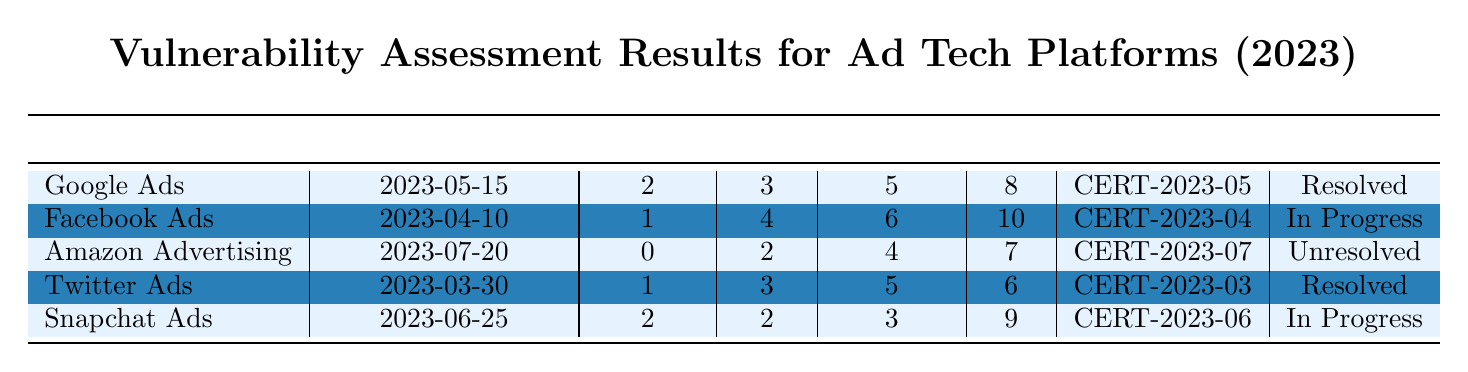What is the status of the vulnerabilities in Facebook Ads? The table shows that Facebook Ads has a status of "In Progress" listed under the Status column.
Answer: In Progress How many critical vulnerabilities were found in Google Ads? Referring to the Google Ads row, the Critical column shows 2 vulnerabilities.
Answer: 2 Which platform has the highest number of high vulnerabilities? By examining the High column, Facebook Ads has 4 high vulnerabilities, which is the maximum compared to other platforms.
Answer: Facebook Ads What is the total number of low vulnerabilities across all platforms? The Low column contains 8 (Google Ads) + 10 (Facebook Ads) + 7 (Amazon Advertising) + 6 (Twitter Ads) + 9 (Snapchat Ads) = 40 total low vulnerabilities.
Answer: 40 What certification date was assigned to Amazon Advertising? Looking at the row for Amazon Advertising, the Certification column indicates "CERT-2023-07".
Answer: CERT-2023-07 Is there any platform that has resolved all its vulnerabilities? Yes, the status of Google Ads and Twitter Ads is "Resolved", indicating that they have addressed their identified vulnerabilities.
Answer: Yes What is the average number of critical vulnerabilities across the platforms? The sum of critical vulnerabilities is 2 (Google Ads) + 1 (Facebook Ads) + 0 (Amazon Advertising) + 1 (Twitter Ads) + 2 (Snapchat Ads) = 6. There are 5 platforms, so the average is 6/5 = 1.2.
Answer: 1.2 Which platform has no critical vulnerabilities? The row for Amazon Advertising shows that it has 0 critical vulnerabilities in the Critical column.
Answer: Amazon Advertising What are the recommended actions for Snapchat Ads? The Recommended Actions listed for Snapchat Ads include establishing a dedicated incident response team, implementing user access controls, and reviewing logging and monitoring solutions.
Answer: Establish a dedicated incident response team, implement user access controls, review logging and monitoring solutions Is the vulnerability status for Amazon Advertising resolved? The table indicates the status for Amazon Advertising is "Unresolved".
Answer: No 